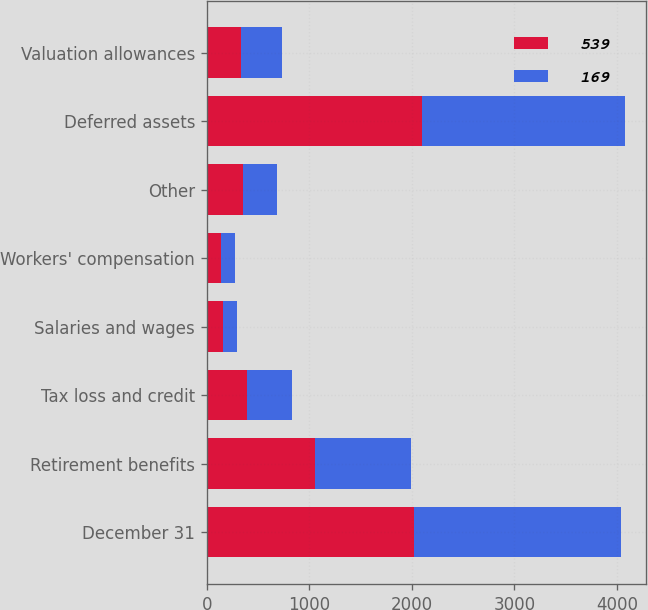Convert chart to OTSL. <chart><loc_0><loc_0><loc_500><loc_500><stacked_bar_chart><ecel><fcel>December 31<fcel>Retirement benefits<fcel>Tax loss and credit<fcel>Salaries and wages<fcel>Workers' compensation<fcel>Other<fcel>Deferred assets<fcel>Valuation allowances<nl><fcel>539<fcel>2018<fcel>1055<fcel>393<fcel>160<fcel>138<fcel>351<fcel>2097<fcel>336<nl><fcel>169<fcel>2017<fcel>935<fcel>437<fcel>137<fcel>139<fcel>335<fcel>1983<fcel>402<nl></chart> 